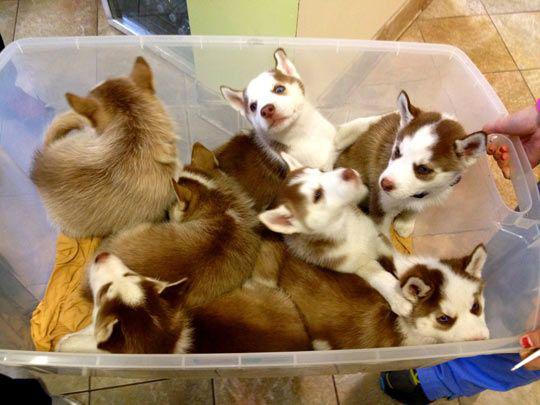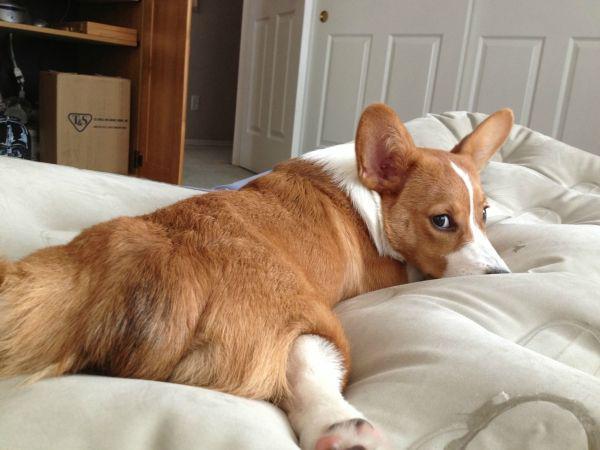The first image is the image on the left, the second image is the image on the right. Analyze the images presented: Is the assertion "There is at least four dogs in the left image." valid? Answer yes or no. Yes. The first image is the image on the left, the second image is the image on the right. For the images displayed, is the sentence "One image contains one orange-and-white corgi posed on its belly with its rear toward the camera." factually correct? Answer yes or no. Yes. 